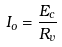<formula> <loc_0><loc_0><loc_500><loc_500>I _ { o } = \frac { E _ { c } } { R _ { v } }</formula> 